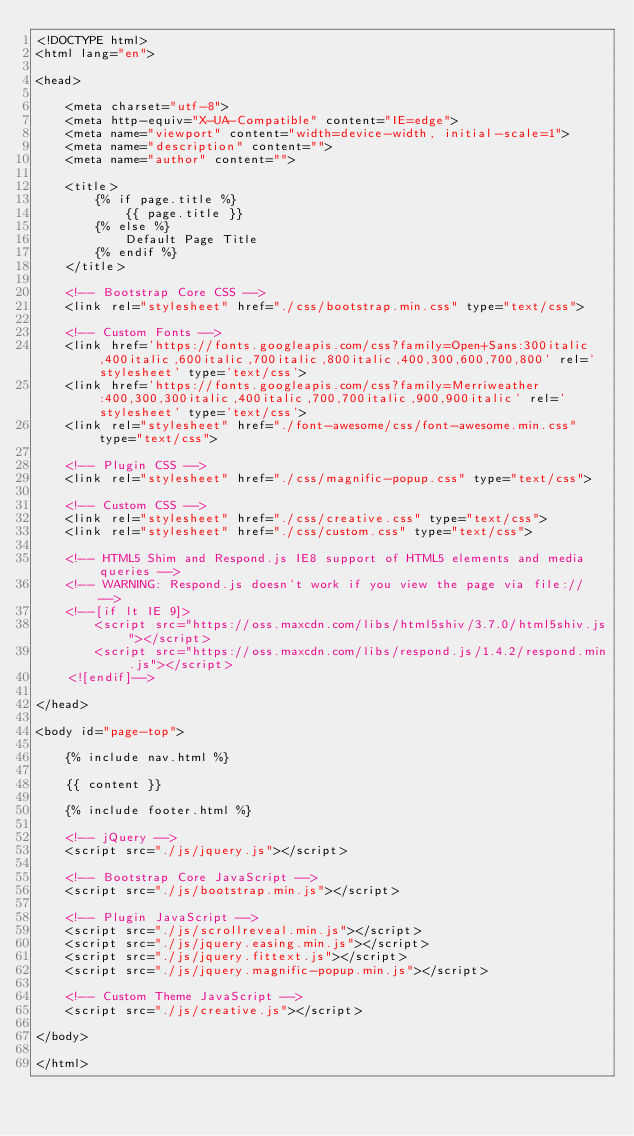<code> <loc_0><loc_0><loc_500><loc_500><_HTML_><!DOCTYPE html>
<html lang="en">

<head>

    <meta charset="utf-8">
    <meta http-equiv="X-UA-Compatible" content="IE=edge">
    <meta name="viewport" content="width=device-width, initial-scale=1">
    <meta name="description" content="">
    <meta name="author" content="">

    <title>
        {% if page.title %}
            {{ page.title }}
        {% else %}
            Default Page Title
        {% endif %}
    </title>

    <!-- Bootstrap Core CSS -->
    <link rel="stylesheet" href="./css/bootstrap.min.css" type="text/css">

    <!-- Custom Fonts -->
    <link href='https://fonts.googleapis.com/css?family=Open+Sans:300italic,400italic,600italic,700italic,800italic,400,300,600,700,800' rel='stylesheet' type='text/css'>
    <link href='https://fonts.googleapis.com/css?family=Merriweather:400,300,300italic,400italic,700,700italic,900,900italic' rel='stylesheet' type='text/css'>
    <link rel="stylesheet" href="./font-awesome/css/font-awesome.min.css" type="text/css">

    <!-- Plugin CSS -->
    <link rel="stylesheet" href="./css/magnific-popup.css" type="text/css">

    <!-- Custom CSS -->
    <link rel="stylesheet" href="./css/creative.css" type="text/css">
    <link rel="stylesheet" href="./css/custom.css" type="text/css">

    <!-- HTML5 Shim and Respond.js IE8 support of HTML5 elements and media queries -->
    <!-- WARNING: Respond.js doesn't work if you view the page via file:// -->
    <!--[if lt IE 9]>
        <script src="https://oss.maxcdn.com/libs/html5shiv/3.7.0/html5shiv.js"></script>
        <script src="https://oss.maxcdn.com/libs/respond.js/1.4.2/respond.min.js"></script>
    <![endif]-->

</head>

<body id="page-top">

    {% include nav.html %}
    
    {{ content }}

    {% include footer.html %}

    <!-- jQuery -->
    <script src="./js/jquery.js"></script>

    <!-- Bootstrap Core JavaScript -->
    <script src="./js/bootstrap.min.js"></script>

    <!-- Plugin JavaScript -->
    <script src="./js/scrollreveal.min.js"></script>
    <script src="./js/jquery.easing.min.js"></script>
    <script src="./js/jquery.fittext.js"></script>
    <script src="./js/jquery.magnific-popup.min.js"></script>

    <!-- Custom Theme JavaScript -->
    <script src="./js/creative.js"></script>

</body>

</html></code> 